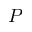<formula> <loc_0><loc_0><loc_500><loc_500>P</formula> 